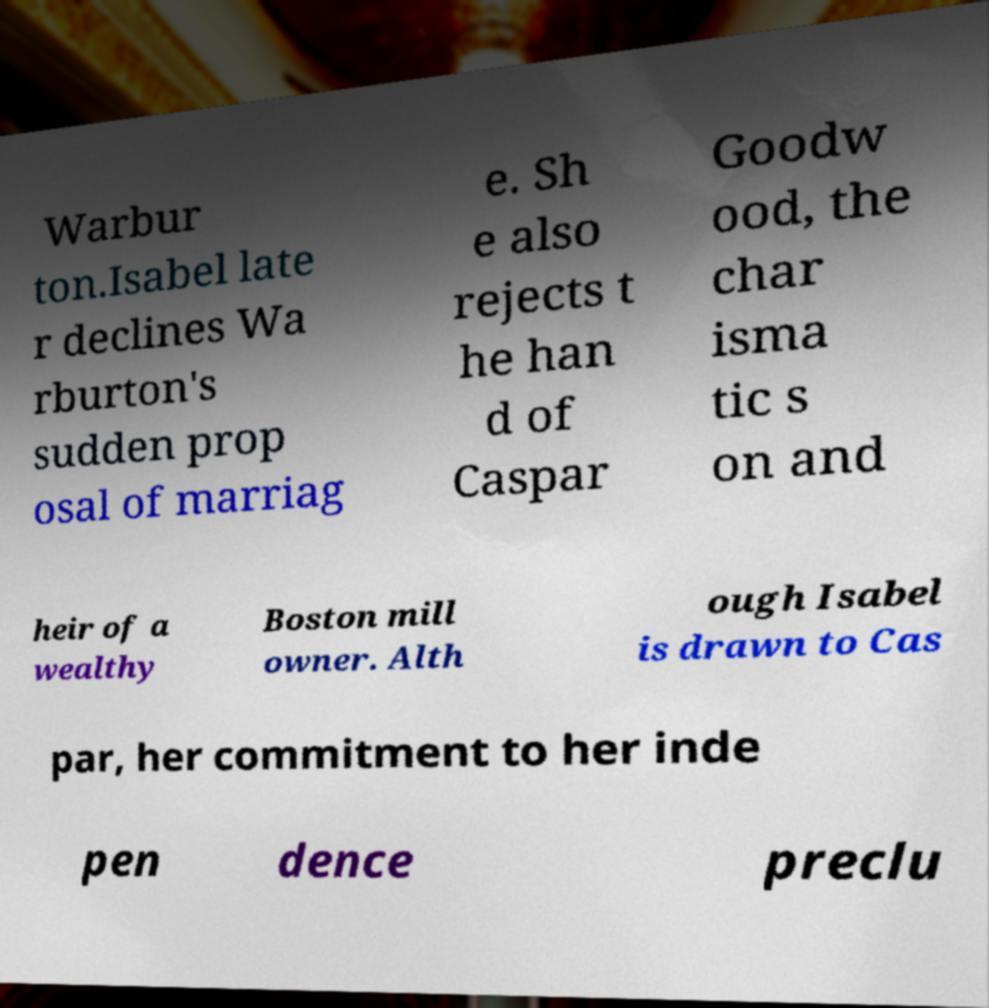I need the written content from this picture converted into text. Can you do that? Warbur ton.Isabel late r declines Wa rburton's sudden prop osal of marriag e. Sh e also rejects t he han d of Caspar Goodw ood, the char isma tic s on and heir of a wealthy Boston mill owner. Alth ough Isabel is drawn to Cas par, her commitment to her inde pen dence preclu 